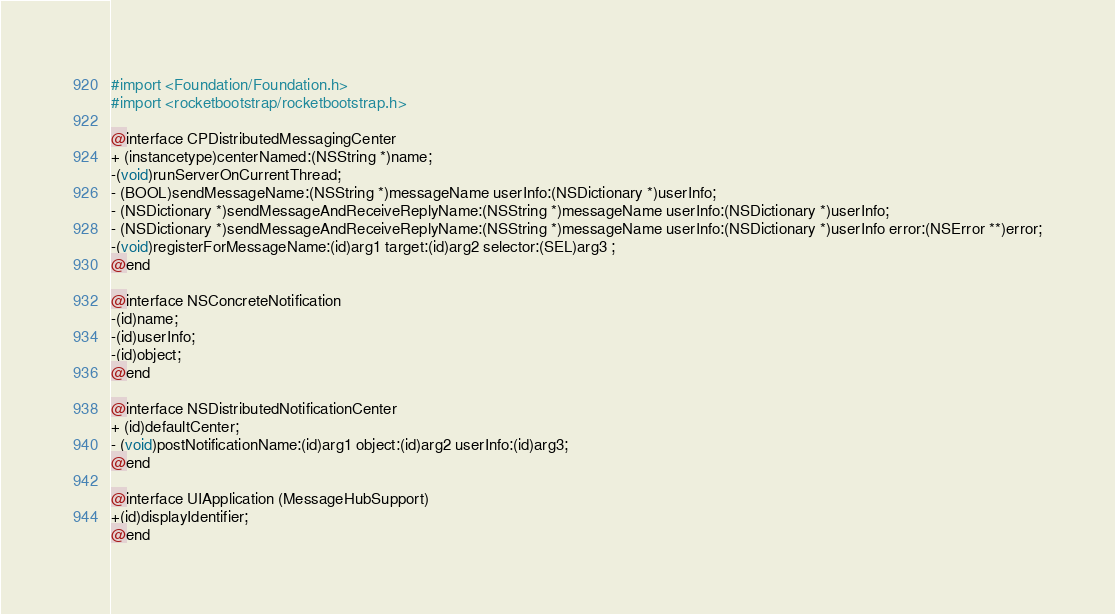<code> <loc_0><loc_0><loc_500><loc_500><_C_>
#import <Foundation/Foundation.h>
#import <rocketbootstrap/rocketbootstrap.h>

@interface CPDistributedMessagingCenter
+ (instancetype)centerNamed:(NSString *)name;
-(void)runServerOnCurrentThread;
- (BOOL)sendMessageName:(NSString *)messageName userInfo:(NSDictionary *)userInfo;
- (NSDictionary *)sendMessageAndReceiveReplyName:(NSString *)messageName userInfo:(NSDictionary *)userInfo;
- (NSDictionary *)sendMessageAndReceiveReplyName:(NSString *)messageName userInfo:(NSDictionary *)userInfo error:(NSError **)error;
-(void)registerForMessageName:(id)arg1 target:(id)arg2 selector:(SEL)arg3 ;
@end

@interface NSConcreteNotification
-(id)name;
-(id)userInfo;
-(id)object;
@end

@interface NSDistributedNotificationCenter
+ (id)defaultCenter;
- (void)postNotificationName:(id)arg1 object:(id)arg2 userInfo:(id)arg3;
@end

@interface UIApplication (MessageHubSupport)
+(id)displayIdentifier;
@end
</code> 